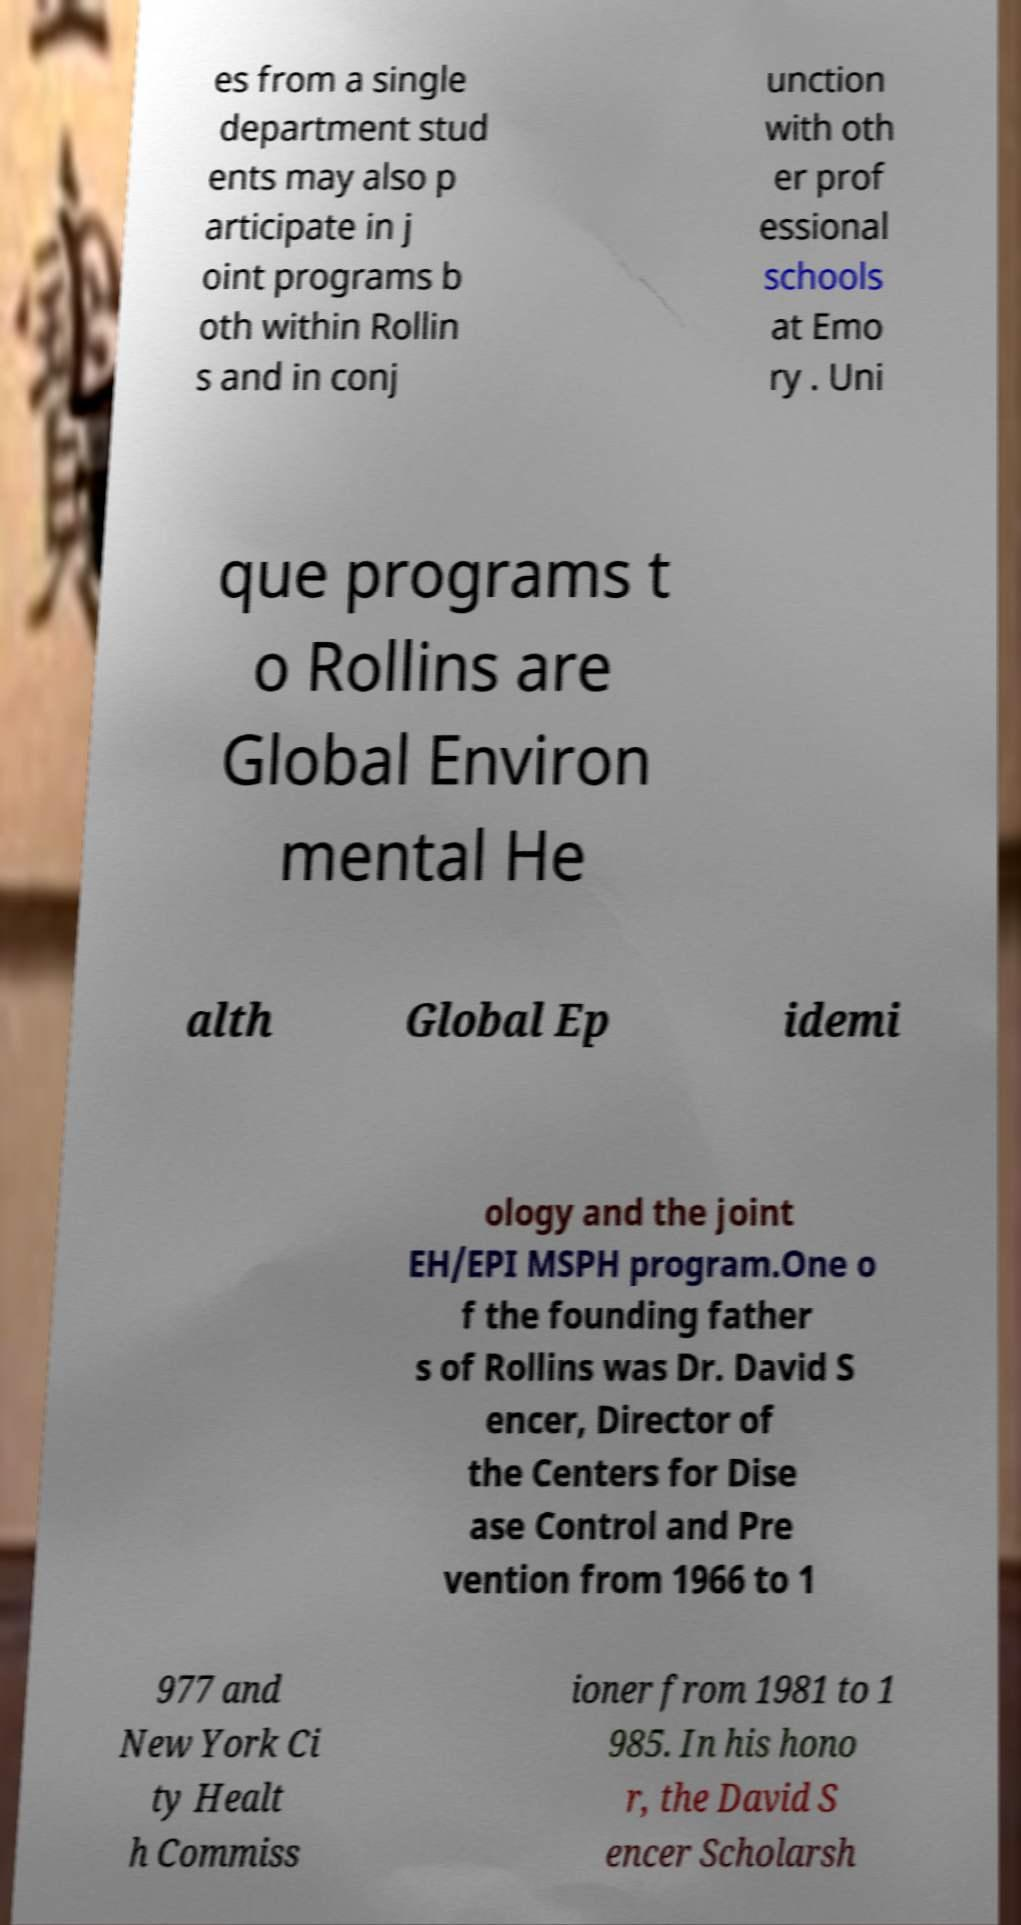I need the written content from this picture converted into text. Can you do that? es from a single department stud ents may also p articipate in j oint programs b oth within Rollin s and in conj unction with oth er prof essional schools at Emo ry . Uni que programs t o Rollins are Global Environ mental He alth Global Ep idemi ology and the joint EH/EPI MSPH program.One o f the founding father s of Rollins was Dr. David S encer, Director of the Centers for Dise ase Control and Pre vention from 1966 to 1 977 and New York Ci ty Healt h Commiss ioner from 1981 to 1 985. In his hono r, the David S encer Scholarsh 